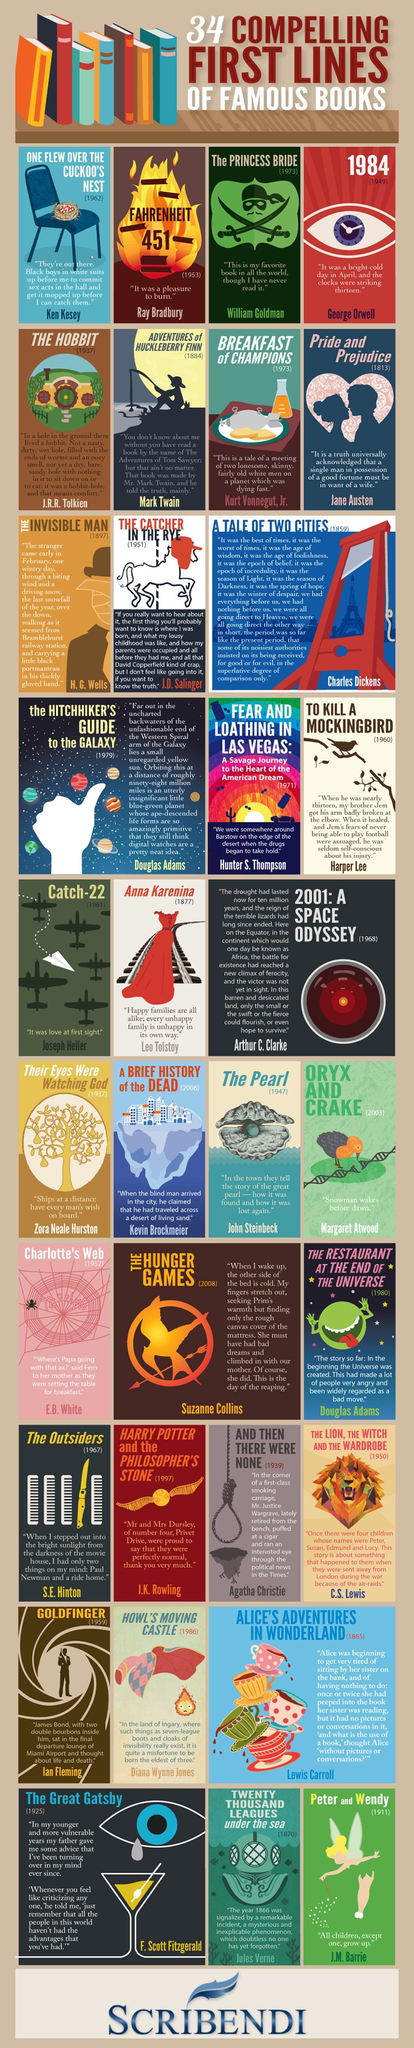who is the author of the book "Anna Karenina"?
Answer the question with a short phrase. Leo Tolstoy what is the first line of the book "Catch-22"? It was love at first sight what is the first line of the book "Peter and Wendy"? All children, except one, grow up who is the author of the book "Catch-22"? Joseph Heller who is the author of the book "to kill a mockingbird"? Harper Lee 